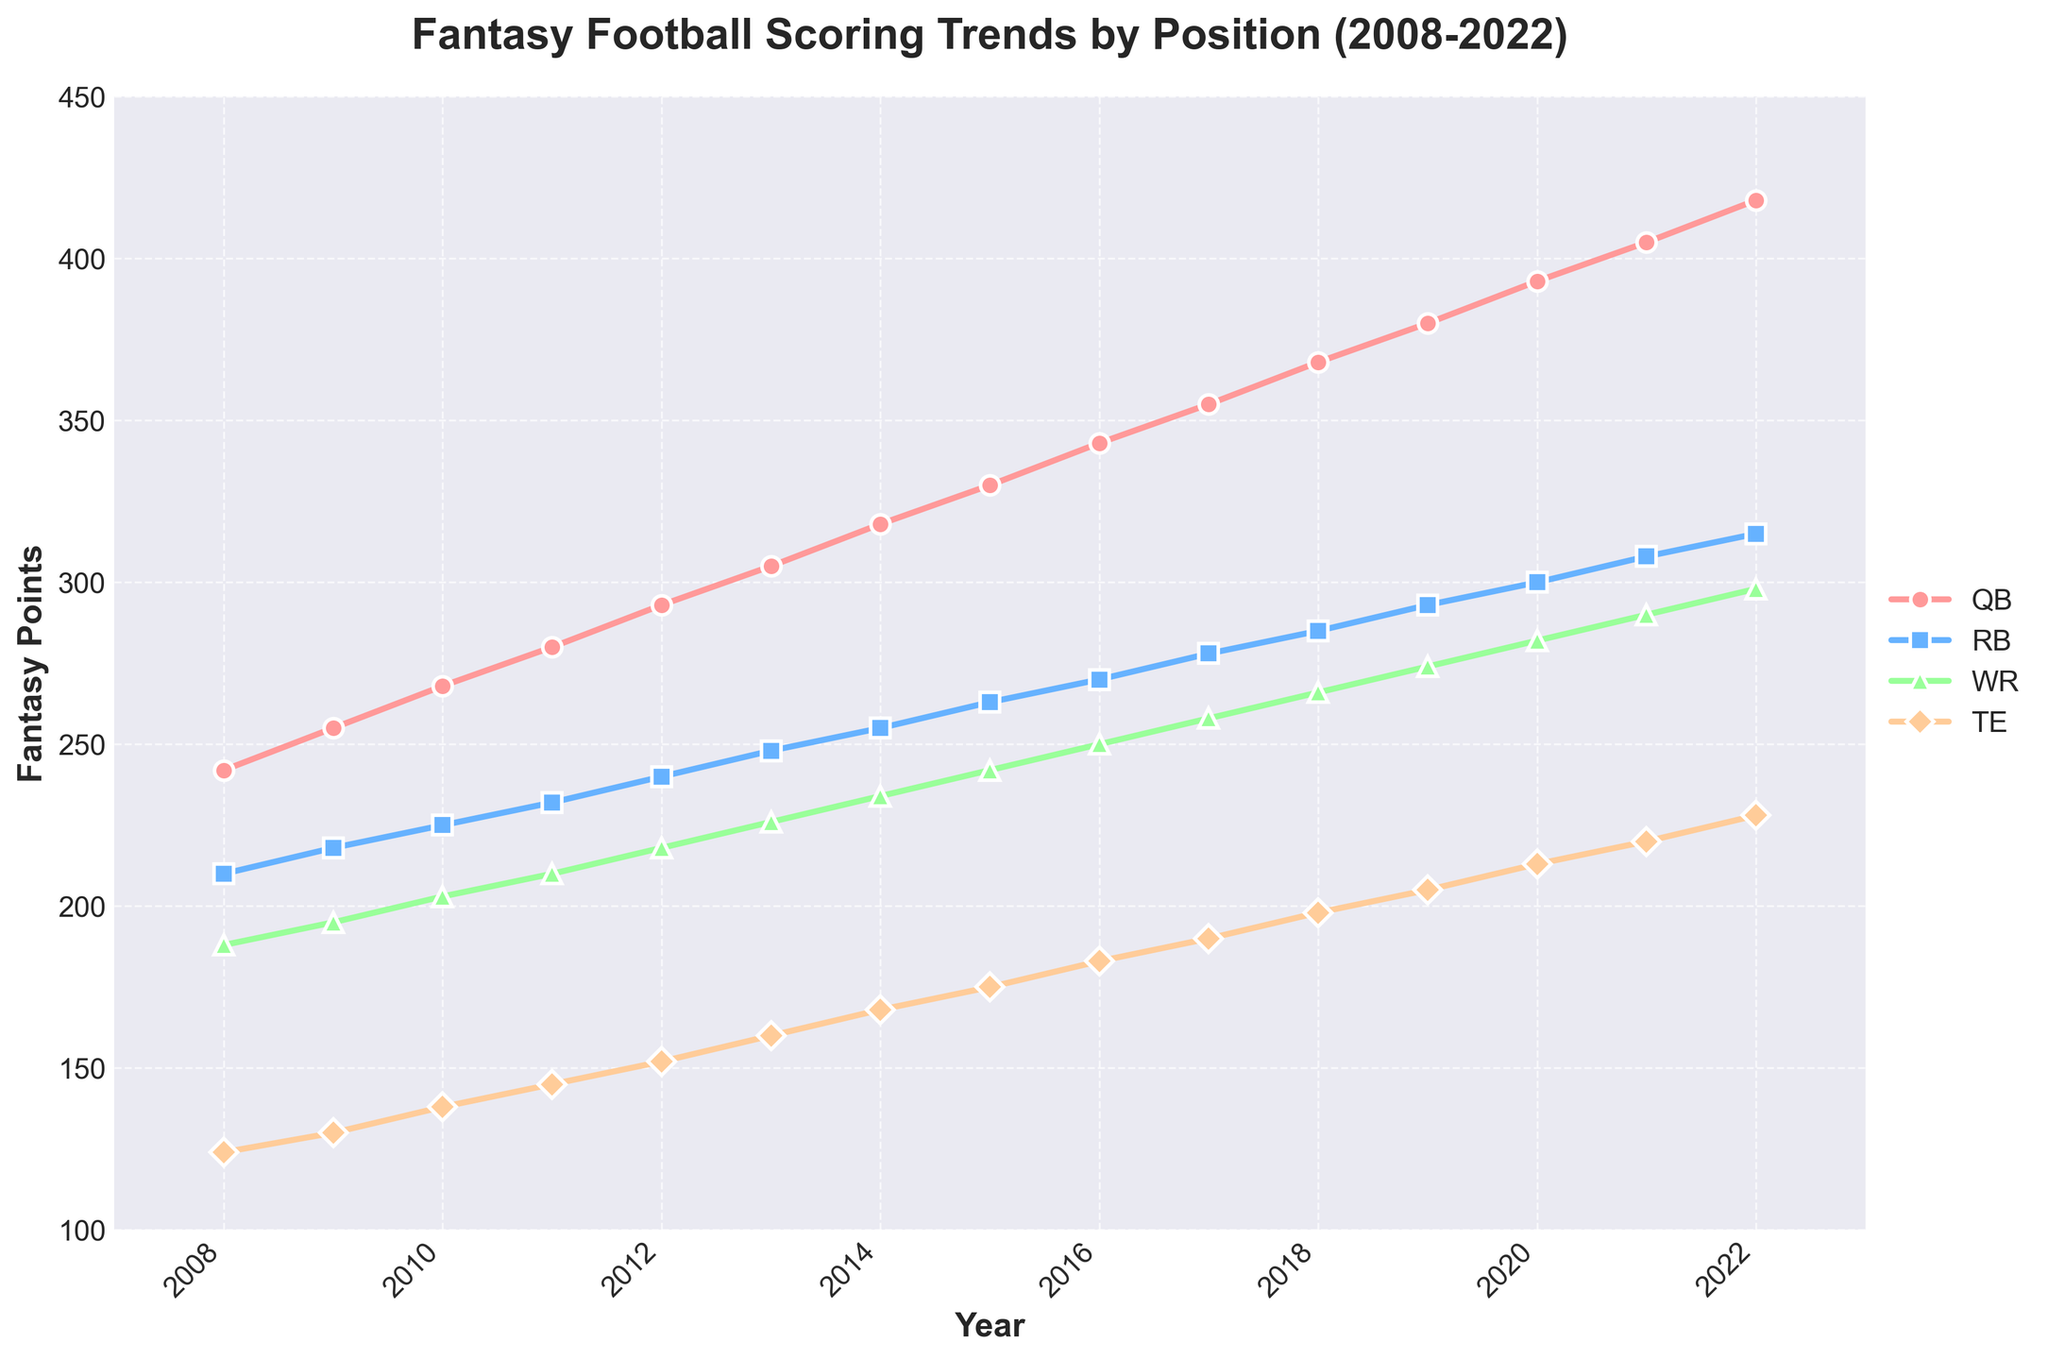What's the average Fantasy Points scored by QBs over the 15 years? Sum all points scored by QBs, which is 242 + 255 + 268 + 280 + 293 + 305 + 318 + 330 + 343 + 355 + 368 + 380 + 393 + 405 + 418 = 4953. Then divide by the number of years (15). 4953 / 15 = 330.2
Answer: 330.2 Which position had the fastest increase in Fantasy Points from 2008 to 2022? Look at the slope of the lines for each position. The QB line has the largest increase, starting at 242 in 2008 and reaching 418 in 2022, an increase of 176 points. No other position shows such a high change.
Answer: QB How many more Fantasy Points did WRs score in 2022 compared to 2008? Subtract the WR scores of 2008 from 2022, which is 298 - 188. 298 - 188 = 110
Answer: 110 Which year did TEs surpass 200 Fantasy Points? Scan through the TE scores to find the first year that exceeds 200 points. In 2019, the TE score is 205, which is the first year over 200 points.
Answer: 2019 How did the RBs' scoring trend compare to WRs' scoring trend between 2015 and 2020? Examine the slopes and numerical differences between RB and WR scores from 2015 (263 for RB and 242 for WR) to 2020 (300 for RB and 282 for WR). RBs increased by 37 points, while WRs increased by 40 points. Both trends show an increase with WRs slightly more.
Answer: Both increased, WRs slightly more Which position had the highest average scoring increase per year from 2008 to 2022? Calculate the increase per year for each position: QB (176 points over 15 years), RB (105 points over 15 years), WR (110 points over 15 years), TE (104 points over 15 years). QB had the highest with 176/15 ≈ 11.73 points per year.
Answer: QB In what year did the gap between QB and RB Fantasy Points first exceed 50 points? Calculate differences each year until the gap exceeds 50 points. The first year is 2016, with QBs at 343 and RBs at 270. The difference is 343 - 270 = 73.
Answer: 2016 Which position had the least variation in scoring from 2008 to 2022? Look for the position with the smallest overall change. TEs started at 124 and reached 228, a change of 104 points, which is smaller than the changes for QB (176), RB (105), and WR (110).
Answer: TE 